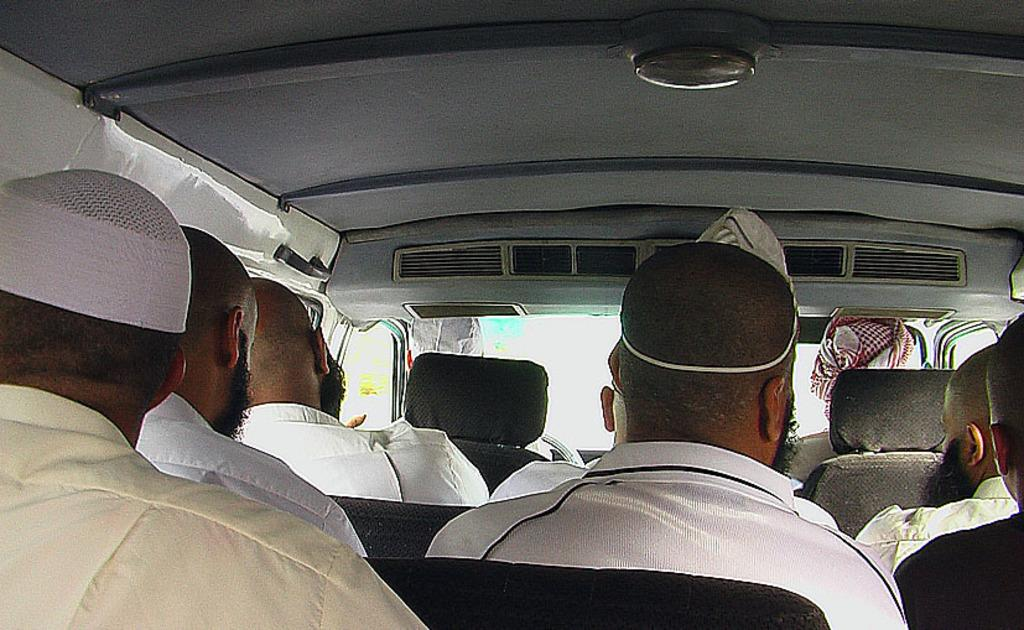What are the people in the image doing? The people in the image are sitting inside a car. What are the people wearing? The people are wearing white dresses. What type of company is the tiger working for in the image? There is no tiger present in the image, so it is not possible to determine what company it might be working for. 